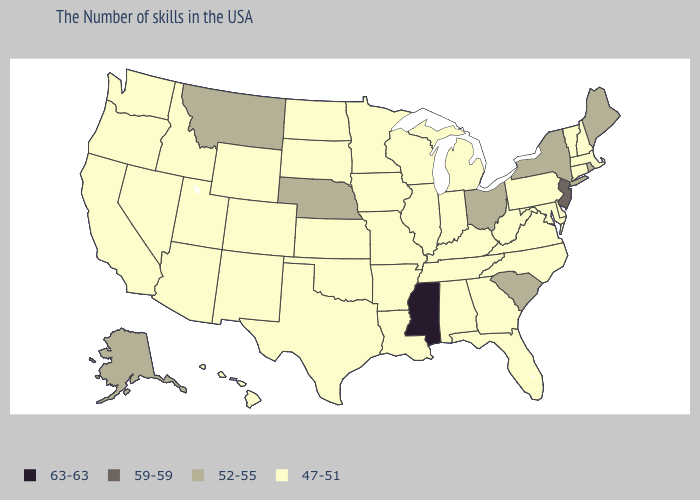Among the states that border Louisiana , which have the highest value?
Keep it brief. Mississippi. Does New Mexico have a lower value than Maine?
Give a very brief answer. Yes. What is the value of Indiana?
Answer briefly. 47-51. Name the states that have a value in the range 63-63?
Give a very brief answer. Mississippi. Name the states that have a value in the range 63-63?
Quick response, please. Mississippi. Name the states that have a value in the range 59-59?
Write a very short answer. New Jersey. Does Oregon have the highest value in the USA?
Answer briefly. No. Does South Dakota have the lowest value in the USA?
Answer briefly. Yes. Name the states that have a value in the range 63-63?
Keep it brief. Mississippi. Name the states that have a value in the range 52-55?
Short answer required. Maine, Rhode Island, New York, South Carolina, Ohio, Nebraska, Montana, Alaska. Does the map have missing data?
Give a very brief answer. No. Among the states that border Tennessee , which have the highest value?
Short answer required. Mississippi. Is the legend a continuous bar?
Answer briefly. No. What is the value of Florida?
Write a very short answer. 47-51. 